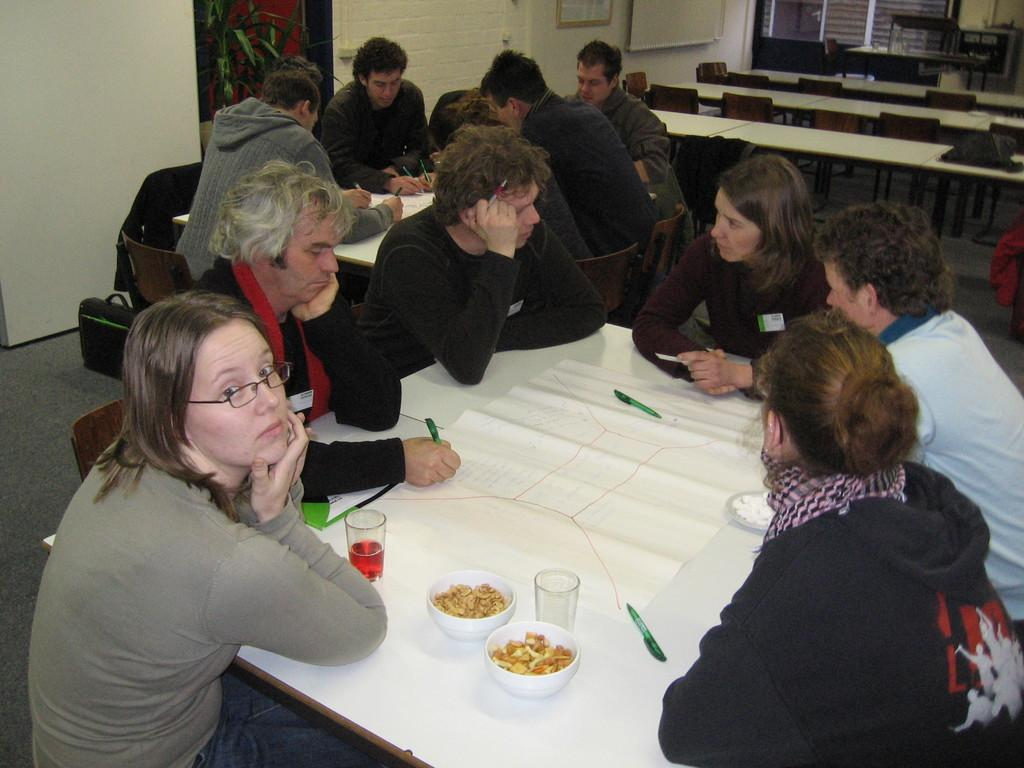What are the people near the table doing in the image? There are people sitting on chairs near a table in the image. What is on the table that they might be using? There is a bowl, food, a glass, paper, and a pen on the table. What might the people be using the pen for? The pen might be used for writing on the paper. How does the feeling of comfort change throughout the image? The image does not depict feelings or comfort levels; it shows people sitting near a table with various items on it. What type of change does the pen undergo in the image? The pen does not undergo any visible changes in the image; it remains stationary on the table. 